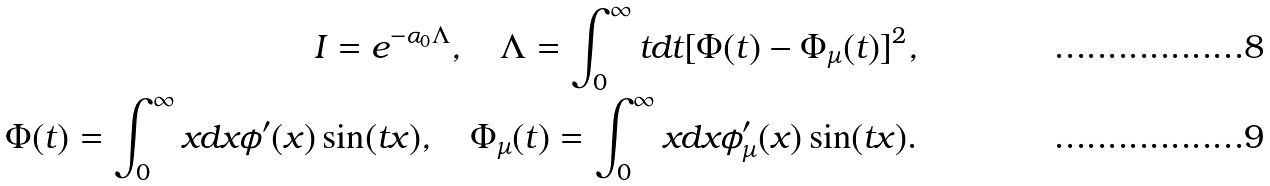<formula> <loc_0><loc_0><loc_500><loc_500>I = e ^ { - \alpha _ { 0 } \Lambda } , \quad \Lambda = \int _ { 0 } ^ { \infty } t d t [ \Phi ( t ) - \Phi _ { \mu } ( t ) ] ^ { 2 } , \\ \Phi ( t ) = \int _ { 0 } ^ { \infty } x d x \phi ^ { \prime } ( x ) \sin ( t x ) , \quad \Phi _ { \mu } ( t ) = \int _ { 0 } ^ { \infty } x d x \phi _ { \mu } ^ { \prime } ( x ) \sin ( t x ) .</formula> 